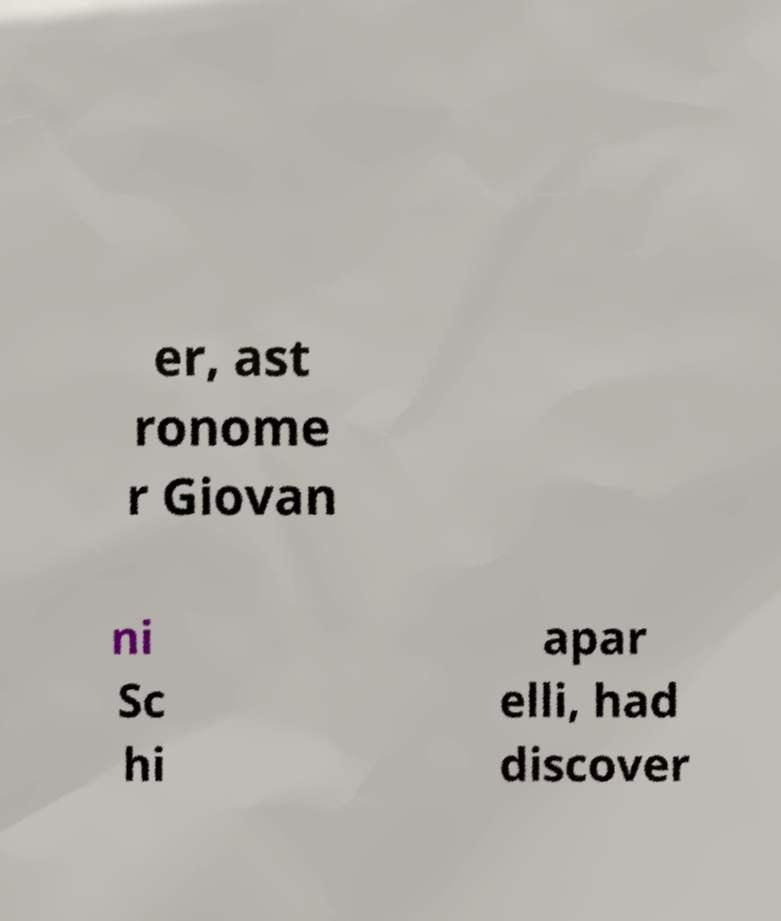There's text embedded in this image that I need extracted. Can you transcribe it verbatim? er, ast ronome r Giovan ni Sc hi apar elli, had discover 